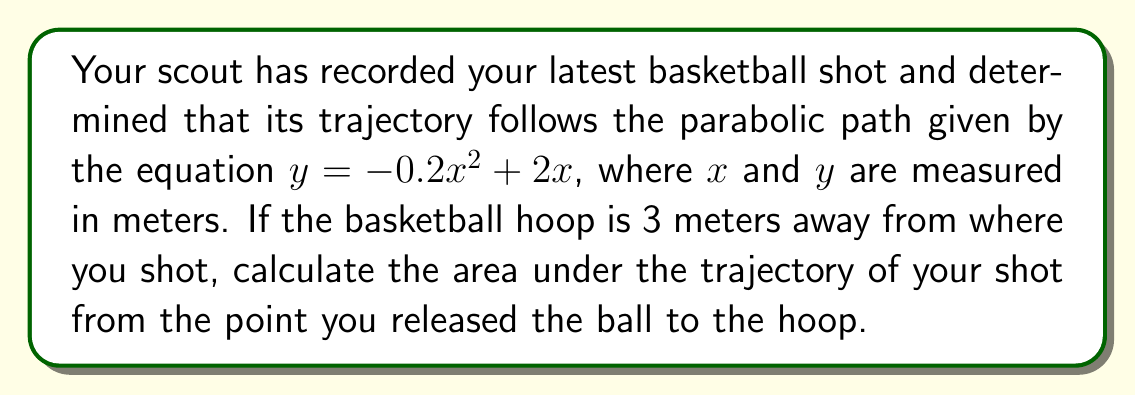Could you help me with this problem? Let's approach this step-by-step:

1) The parabolic trajectory is given by $y = -0.2x^2 + 2x$

2) We need to find the area under this curve from $x = 0$ (where you shot) to $x = 3$ (where the hoop is)

3) To find the area under a curve, we use definite integration:

   $$\text{Area} = \int_0^3 (-0.2x^2 + 2x) dx$$

4) Let's integrate this function:
   
   $$\int (-0.2x^2 + 2x) dx = -\frac{0.2x^3}{3} + x^2 + C$$

5) Now, we apply the limits:

   $$\text{Area} = \left[-\frac{0.2x^3}{3} + x^2\right]_0^3$$

6) Evaluate at $x = 3$:
   
   $$-\frac{0.2(3^3)}{3} + 3^2 = -1.8 + 9 = 7.2$$

7) Evaluate at $x = 0$:
   
   $$-\frac{0.2(0^3)}{3} + 0^2 = 0$$

8) Subtract the results:

   $$7.2 - 0 = 7.2$$

Therefore, the area under the trajectory from where you shot to the hoop is 7.2 square meters.
Answer: 7.2 m² 